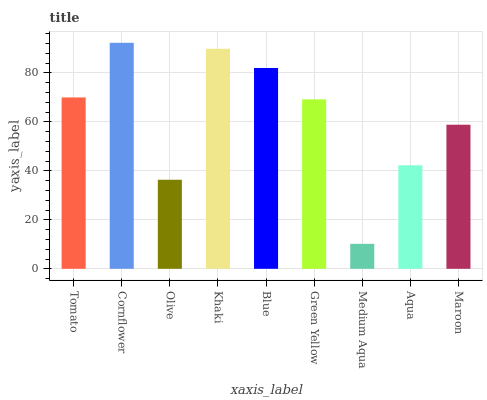Is Olive the minimum?
Answer yes or no. No. Is Olive the maximum?
Answer yes or no. No. Is Cornflower greater than Olive?
Answer yes or no. Yes. Is Olive less than Cornflower?
Answer yes or no. Yes. Is Olive greater than Cornflower?
Answer yes or no. No. Is Cornflower less than Olive?
Answer yes or no. No. Is Green Yellow the high median?
Answer yes or no. Yes. Is Green Yellow the low median?
Answer yes or no. Yes. Is Khaki the high median?
Answer yes or no. No. Is Cornflower the low median?
Answer yes or no. No. 